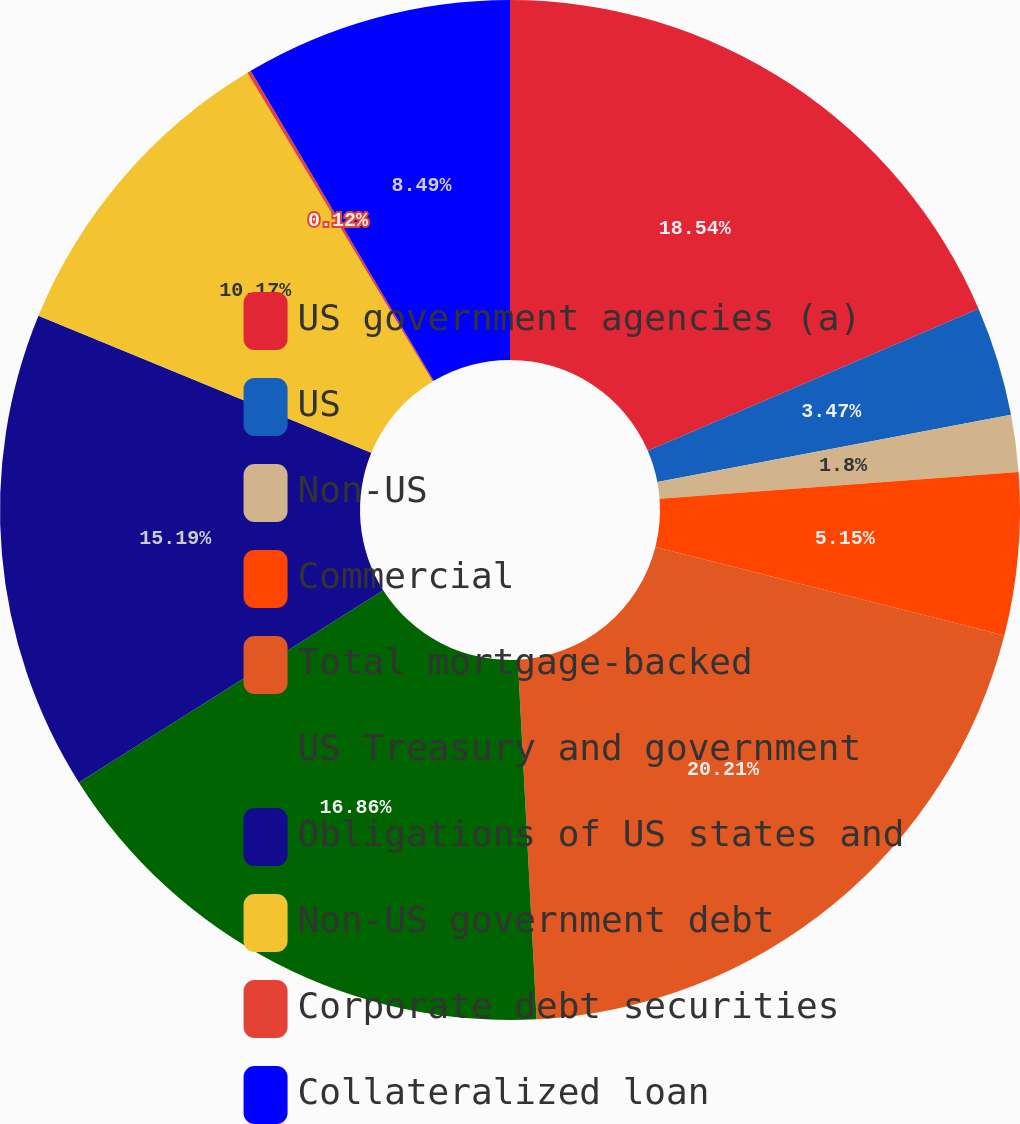Convert chart to OTSL. <chart><loc_0><loc_0><loc_500><loc_500><pie_chart><fcel>US government agencies (a)<fcel>US<fcel>Non-US<fcel>Commercial<fcel>Total mortgage-backed<fcel>US Treasury and government<fcel>Obligations of US states and<fcel>Non-US government debt<fcel>Corporate debt securities<fcel>Collateralized loan<nl><fcel>18.54%<fcel>3.47%<fcel>1.8%<fcel>5.15%<fcel>20.21%<fcel>16.86%<fcel>15.19%<fcel>10.17%<fcel>0.12%<fcel>8.49%<nl></chart> 